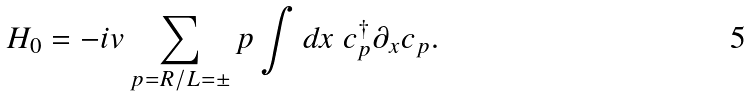Convert formula to latex. <formula><loc_0><loc_0><loc_500><loc_500>H _ { 0 } = - i v \sum _ { p = R / L = \pm } p \int d x \ c _ { p } ^ { \dagger } \partial _ { x } c _ { p } .</formula> 